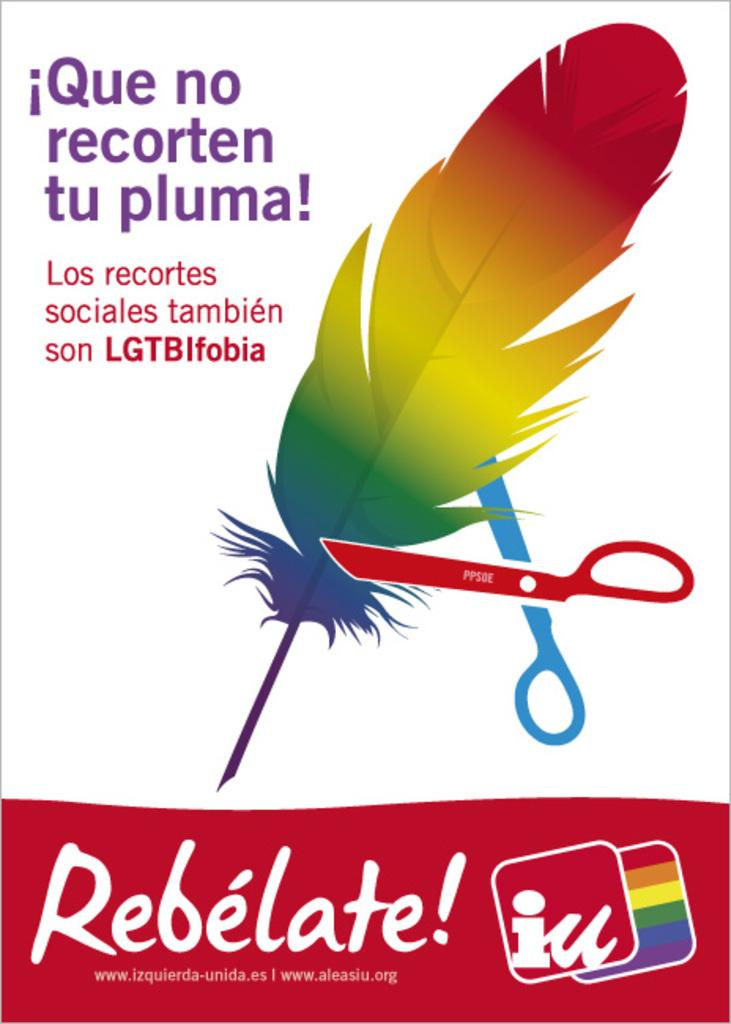<image>
Write a terse but informative summary of the picture. An advertisement supporting LGTB issues shows a pair of scissors attempting to cut a rainbow feather. 